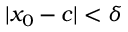<formula> <loc_0><loc_0><loc_500><loc_500>| x _ { 0 } - c | < \delta</formula> 